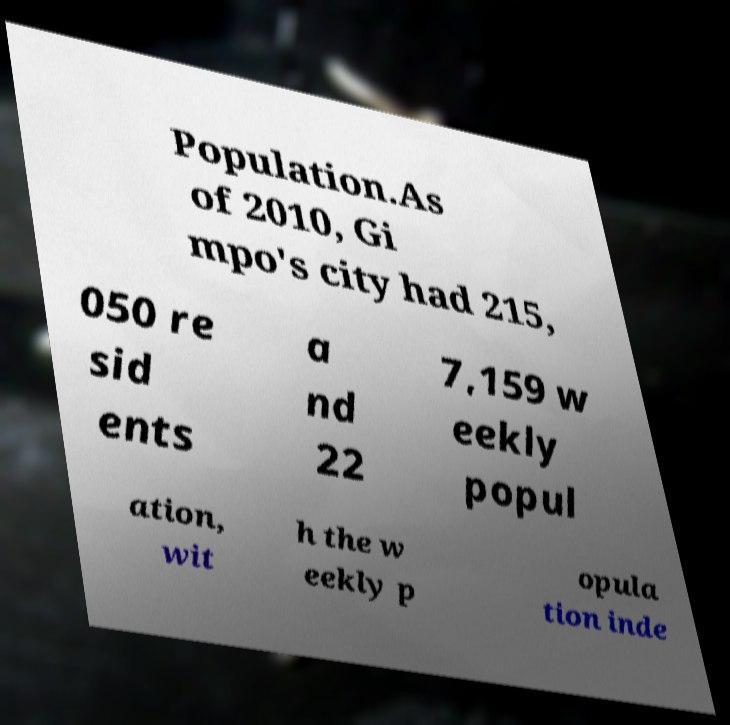Can you accurately transcribe the text from the provided image for me? Population.As of 2010, Gi mpo's city had 215, 050 re sid ents a nd 22 7,159 w eekly popul ation, wit h the w eekly p opula tion inde 